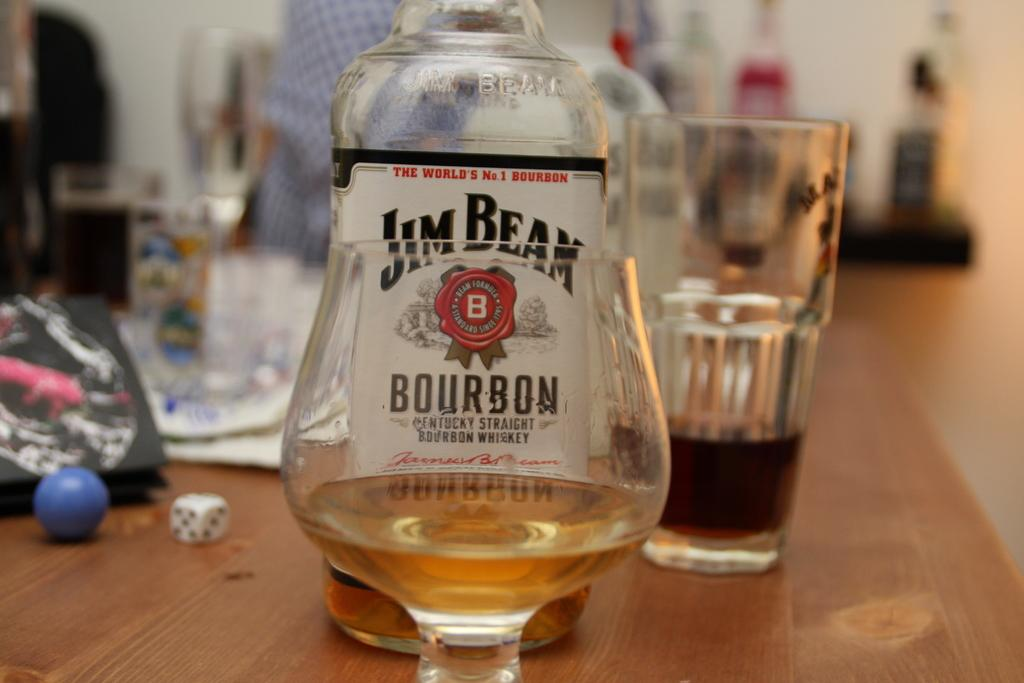<image>
Present a compact description of the photo's key features. Jim Beam Bourbon was poured into the clear glass. 